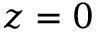<formula> <loc_0><loc_0><loc_500><loc_500>z = 0</formula> 